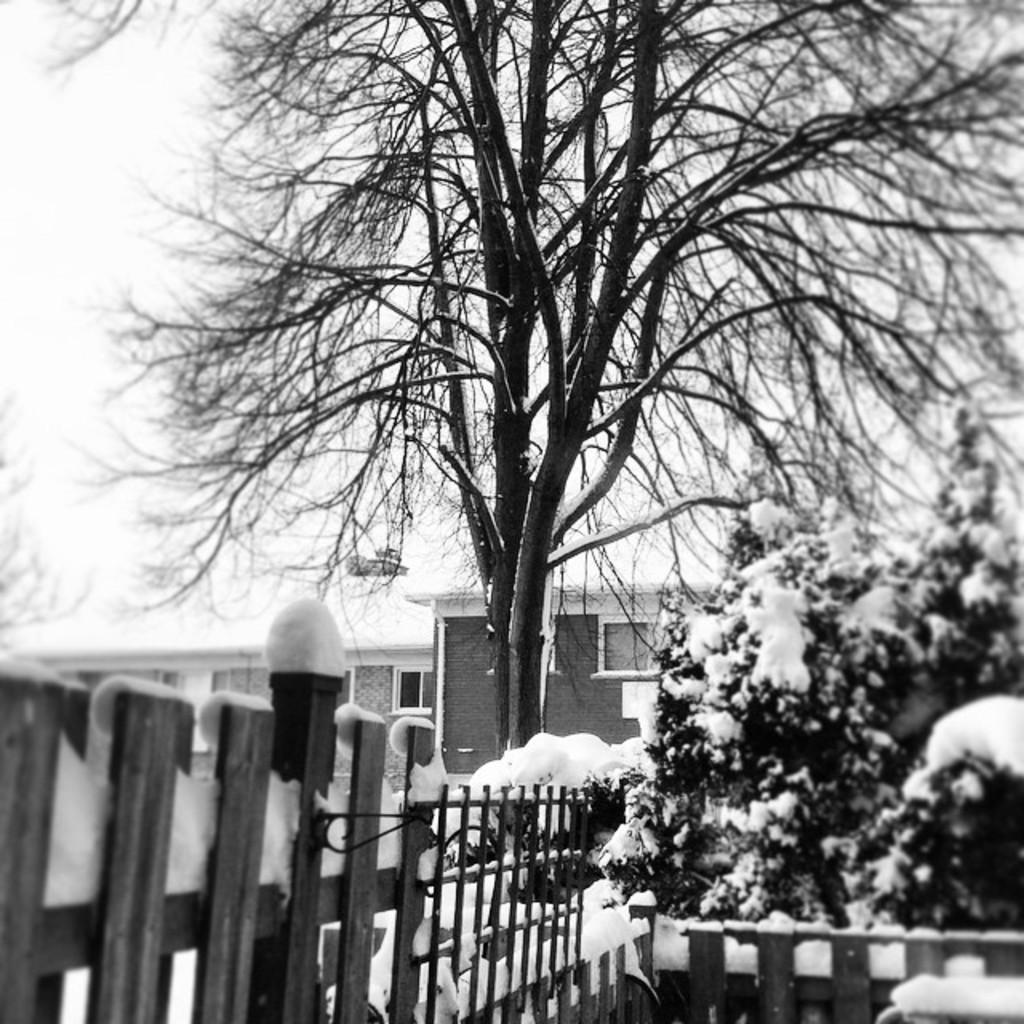What type of fence can be seen in the image? There is a wooden fence in the image. What is covering the trees in the image? Snow is present on the trees. What can be seen in the distance in the image? There are buildings in the background of the image. What is visible at the top of the image? The sky is visible at the top of the image. What type of harbor can be seen in the image? There is no harbor present in the image. How does the son of the owner of the building feel about the snow? There is no information about the son of the owner of the building in the image. 